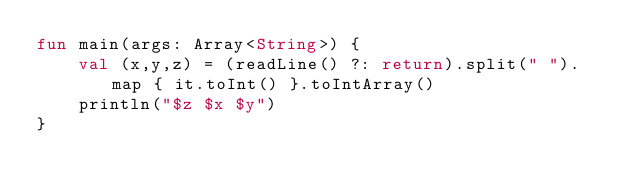Convert code to text. <code><loc_0><loc_0><loc_500><loc_500><_Kotlin_>fun main(args: Array<String>) {
	val (x,y,z) = (readLine() ?: return).split(" ").map { it.toInt() }.toIntArray()
	println("$z $x $y")
}</code> 